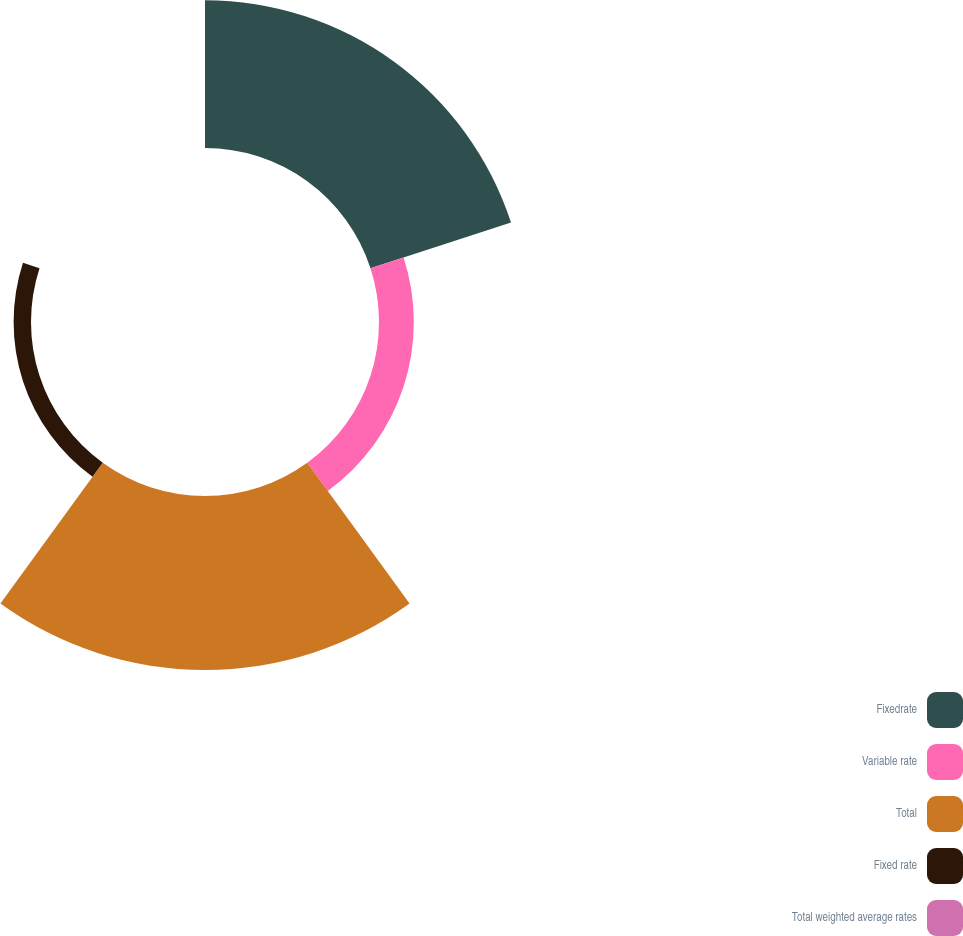Convert chart to OTSL. <chart><loc_0><loc_0><loc_500><loc_500><pie_chart><fcel>Fixedrate<fcel>Variable rate<fcel>Total<fcel>Fixed rate<fcel>Total weighted average rates<nl><fcel>39.51%<fcel>9.31%<fcel>46.53%<fcel>4.65%<fcel>0.0%<nl></chart> 